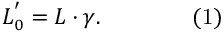Convert formula to latex. <formula><loc_0><loc_0><loc_500><loc_500>L _ { 0 } ^ { ^ { \prime } } = L \cdot \gamma . \quad { ( 1 ) }</formula> 